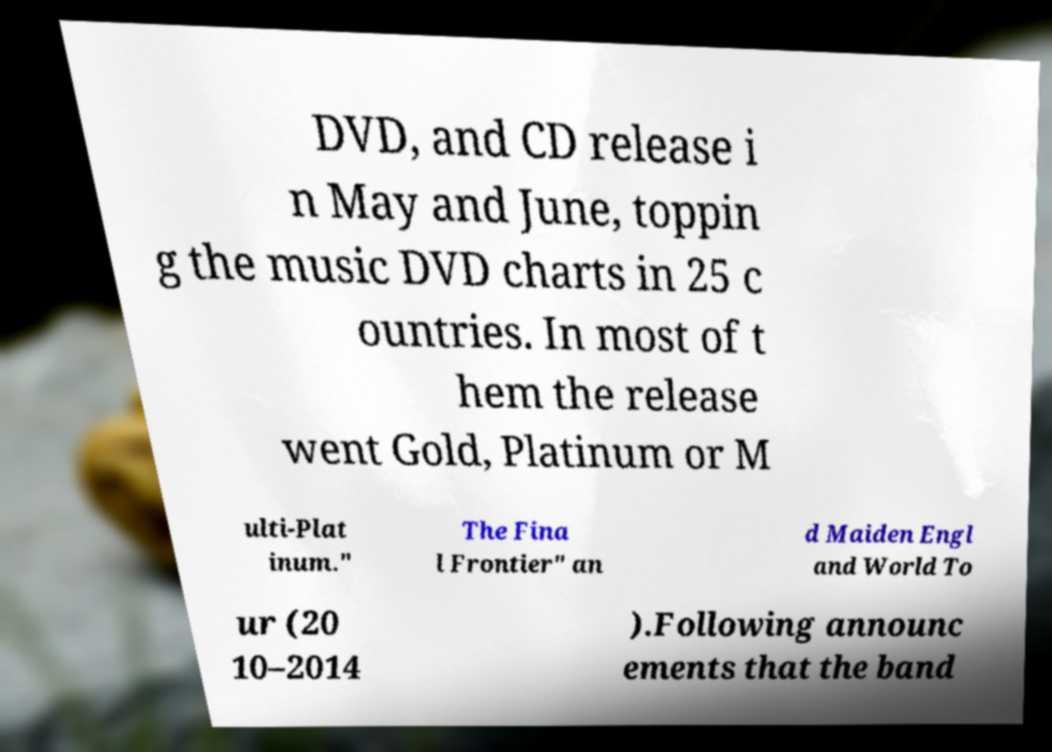There's text embedded in this image that I need extracted. Can you transcribe it verbatim? DVD, and CD release i n May and June, toppin g the music DVD charts in 25 c ountries. In most of t hem the release went Gold, Platinum or M ulti-Plat inum." The Fina l Frontier" an d Maiden Engl and World To ur (20 10–2014 ).Following announc ements that the band 